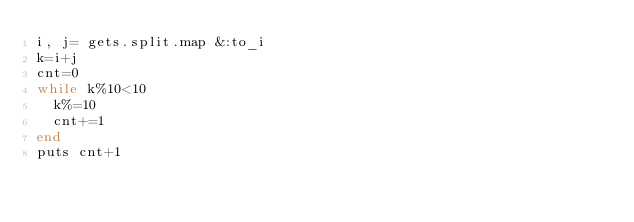Convert code to text. <code><loc_0><loc_0><loc_500><loc_500><_Ruby_>i, j= gets.split.map &:to_i
k=i+j
cnt=0
while k%10<10
  k%=10
  cnt+=1
end
puts cnt+1</code> 